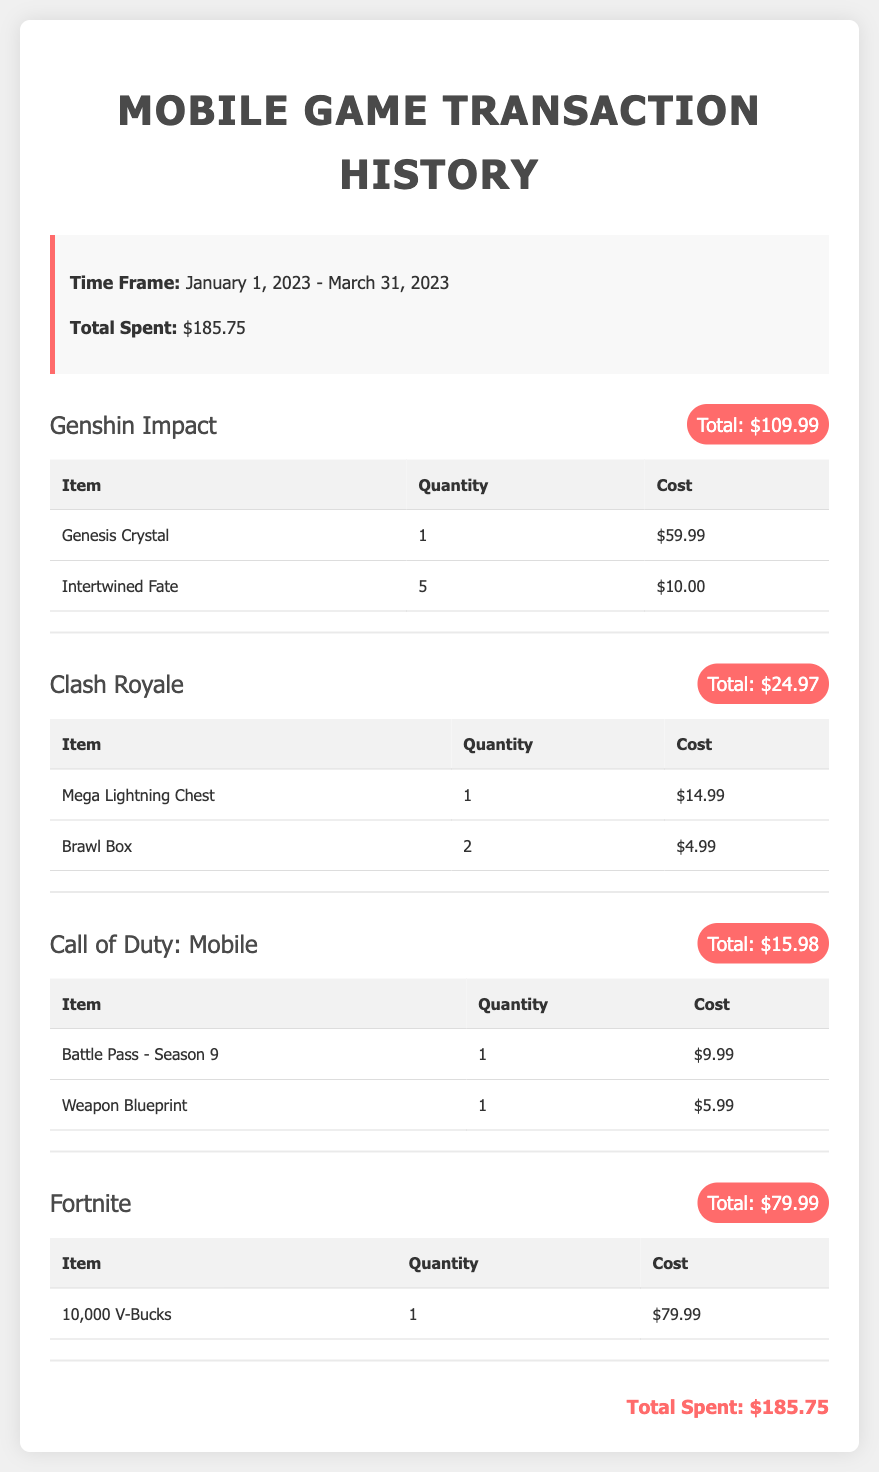What is the total amount spent on Genshin Impact? The total amount spent on Genshin Impact is specified in the document as $109.99.
Answer: $109.99 How many Clash Royale Brawl Boxes were purchased? The number of Brawl Boxes purchased in Clash Royale is listed as 2.
Answer: 2 What was the cost of the 10,000 V-Bucks in Fortnite? The document states that the cost of the 10,000 V-Bucks in Fortnite is $79.99.
Answer: $79.99 What is the total amount spent on in-game purchases from January 1, 2023 to March 31, 2023? The total spent during the specified time frame is presented as $185.75.
Answer: $185.75 Which game had an item costing $59.99? The item costing $59.99 is from Genshin Impact, specifically for Genesis Crystal.
Answer: Genshin Impact What is the quantity of the Battle Pass purchased in Call of Duty: Mobile? The quantity of the Battle Pass purchased is specifically noted as 1.
Answer: 1 How many games are listed in the transaction history? The document outlines transactions for 4 games in total.
Answer: 4 Which game had multiple purchases but the total was $24.97? Clash Royale had multiple purchases with a total amount of $24.97.
Answer: Clash Royale What was the cost of the Weapon Blueprint in Call of Duty: Mobile? The cost for the Weapon Blueprint in Call of Duty: Mobile is documented as $5.99.
Answer: $5.99 